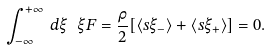<formula> <loc_0><loc_0><loc_500><loc_500>\int _ { - \infty } ^ { + \infty } \, d \xi \ \xi F = \frac { \rho } { 2 } [ \langle s \xi _ { - } \rangle + \langle s \xi _ { + } \rangle ] = 0 .</formula> 